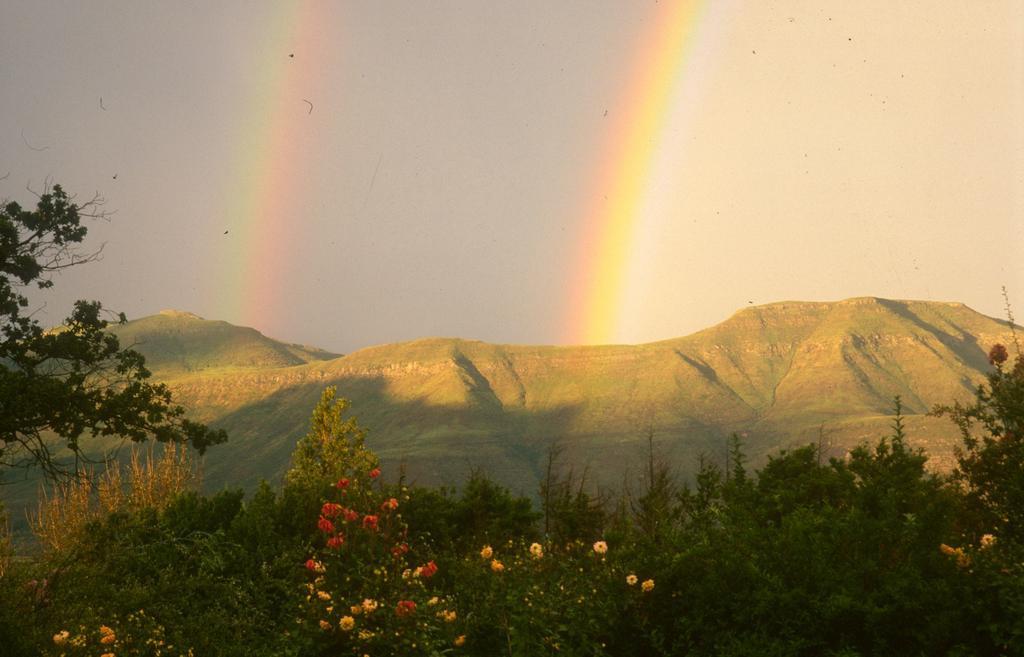In one or two sentences, can you explain what this image depicts? In this image we can see some trees and plants with flowers and in the background, we can see the mountains and at the top we can see the sky with double rainbow. 